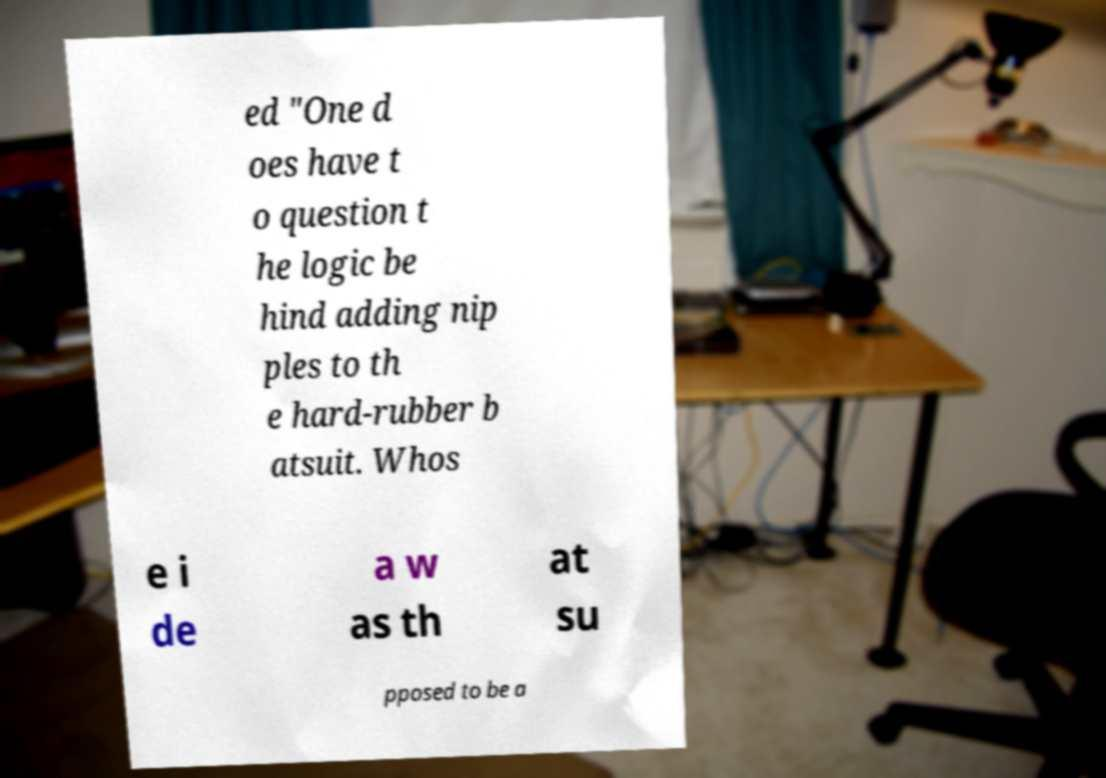There's text embedded in this image that I need extracted. Can you transcribe it verbatim? ed "One d oes have t o question t he logic be hind adding nip ples to th e hard-rubber b atsuit. Whos e i de a w as th at su pposed to be a 